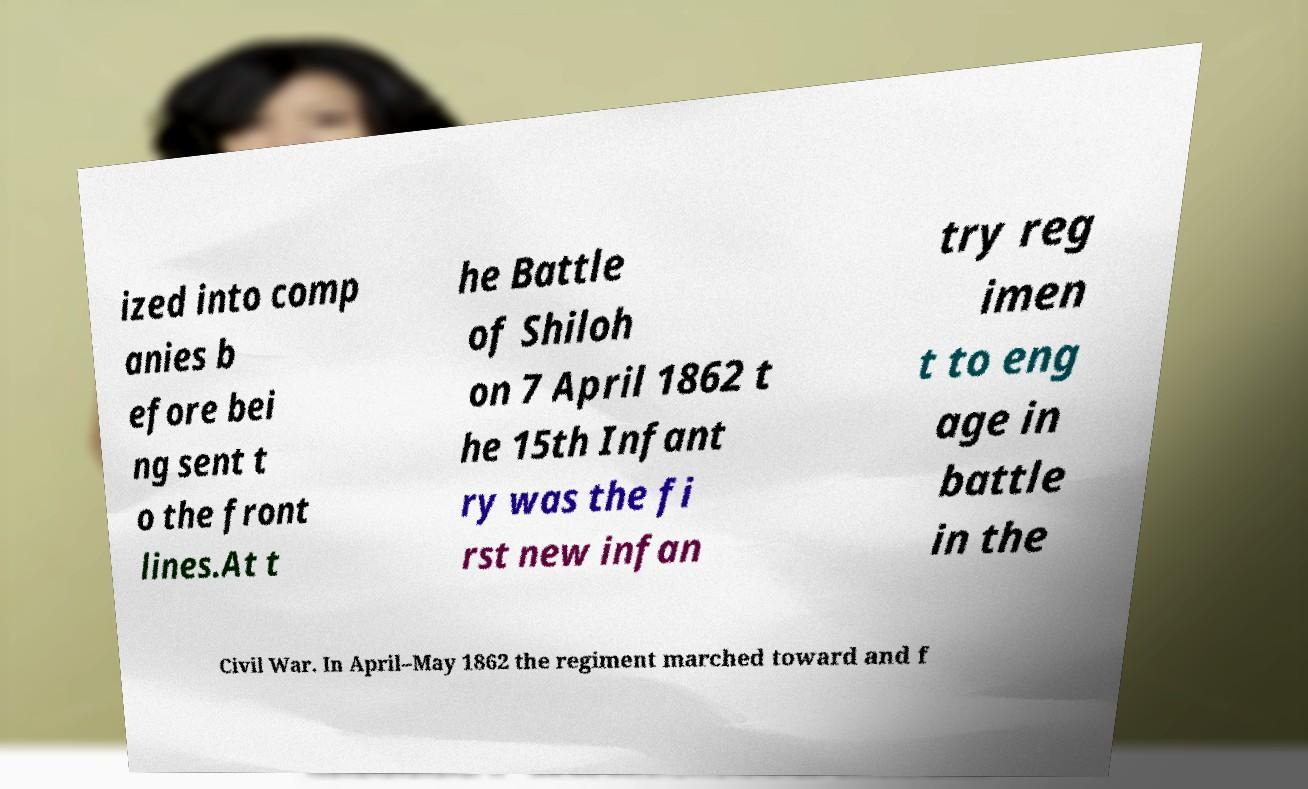For documentation purposes, I need the text within this image transcribed. Could you provide that? ized into comp anies b efore bei ng sent t o the front lines.At t he Battle of Shiloh on 7 April 1862 t he 15th Infant ry was the fi rst new infan try reg imen t to eng age in battle in the Civil War. In April–May 1862 the regiment marched toward and f 